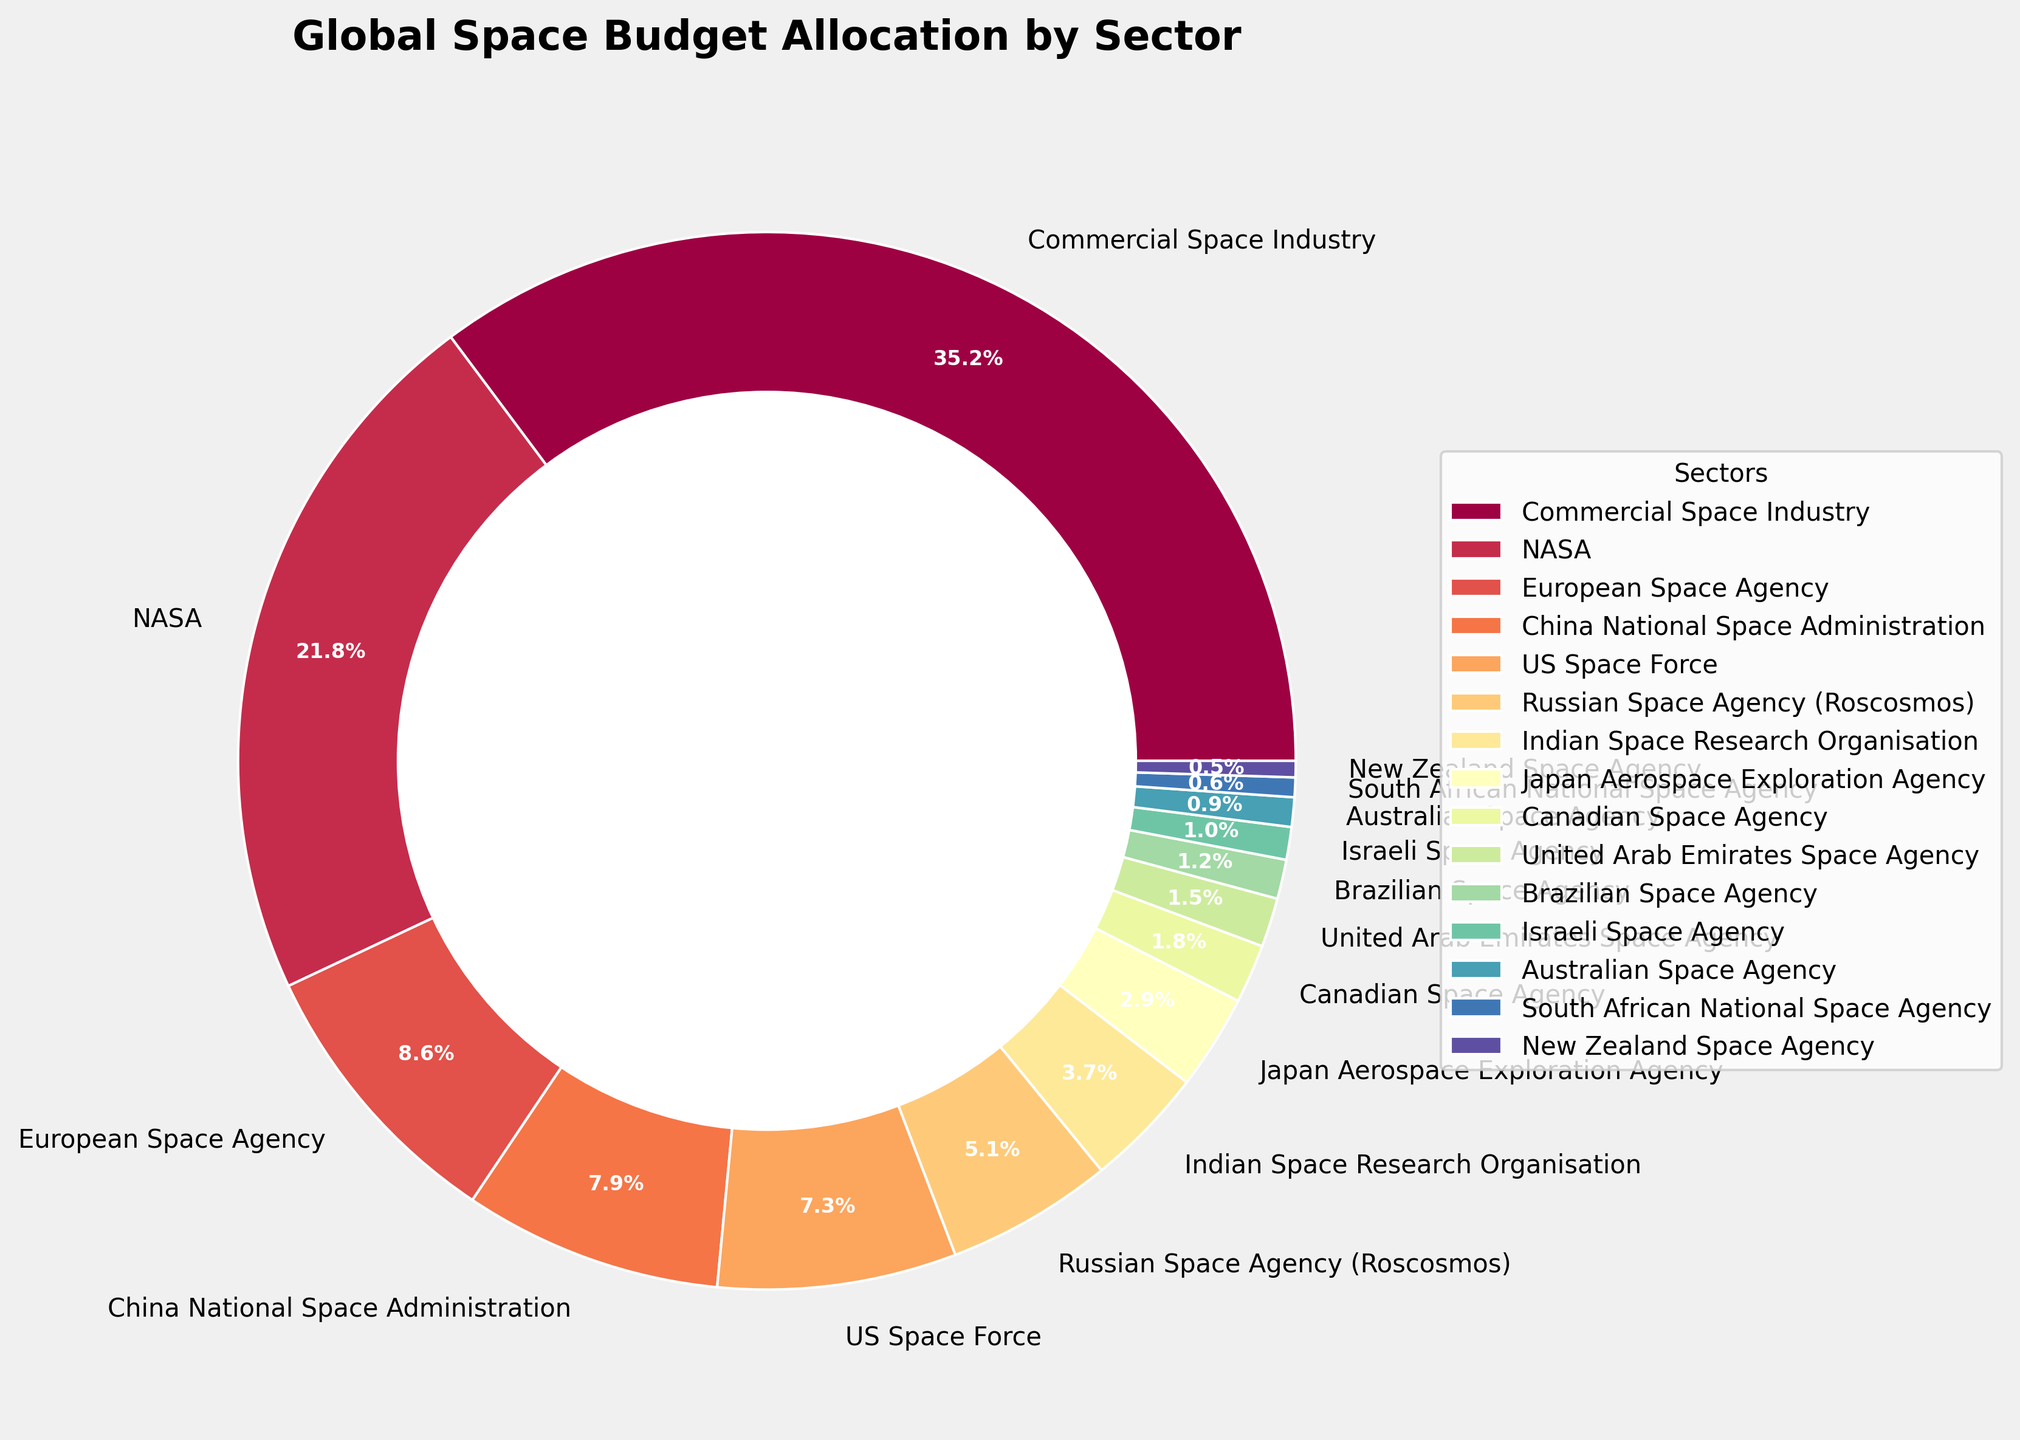Which sector has the highest budget allocation? By looking at the pie chart, the sector with the largest wedge or segment will have the highest budget allocation.
Answer: Commercial Space Industry What is the combined budget allocation for NASA and the US Space Force? Identify the percentage slices for NASA (21.8%) and the US Space Force (7.3%) on the pie chart, then add them together. 21.8 + 7.3 = 29.1%
Answer: 29.1% Is the budget allocation for China National Space Administration greater than the Russian Space Agency? Compare the respective slices of the pie chart for China National Space Administration (7.9%) and the Russian Space Agency (5.1%) to see which has a greater percentage.
Answer: Yes What is the difference in budget allocation between the European Space Agency and the Indian Space Research Organisation? Find the slices for the European Space Agency (8.6%) and the Indian Space Research Organisation (3.7%) on the pie chart and subtract the smaller percentage from the larger one. 8.6 - 3.7 = 4.9%
Answer: 4.9% What sectors make up less than 1% of the global space budget? Locate and read the sectors with slices on the pie chart that are less than 1%. From the chart, these would be the Israeli Space Agency (1.0%), Australian Space Agency (0.9%), South African National Space Agency (0.6%), and New Zealand Space Agency (0.5%).
Answer: Australian Space Agency, South African National Space Agency, New Zealand Space Agency Which sector has the smallest budget allocation? Find the smallest slice on the pie chart to determine the sector with the smallest budget allocation.
Answer: New Zealand Space Agency What is the total budget allocation for all the space agencies in Asia? Identify and sum the allocation percentages for all space agencies in Asia: China National Space Administration (7.9%), Indian Space Research Organisation (3.7%), and Japan Aerospace Exploration Agency (2.9%). 7.9 + 3.7 + 2.9 = 14.5%
Answer: 14.5% How does the budget allocation for the Canadian Space Agency compare to the United Arab Emirates Space Agency? By comparing their slices in the pie chart, the Canadian Space Agency is 1.8% and the United Arab Emirates Space Agency is 1.5%.
Answer: The Canadian Space Agency has a larger budget allocation If you combine the budget allocation of the Russian Space Agency and the European Space Agency, does it surpass the allocation for NASA? Sum the percentages of the Russian Space Agency (5.1%) and the European Space Agency (8.6%) which equals 13.7%. Compare this sum to NASA's allocation of 21.8%. 13.7% < 21.8%, so it does not surpass NASA.
Answer: No What are the top three sectors in terms of budget allocation? Identify the three largest slices in the pie chart: Commercial Space Industry (35.2%), NASA (21.8%), and European Space Agency (8.6%).
Answer: Commercial Space Industry, NASA, European Space Agency 